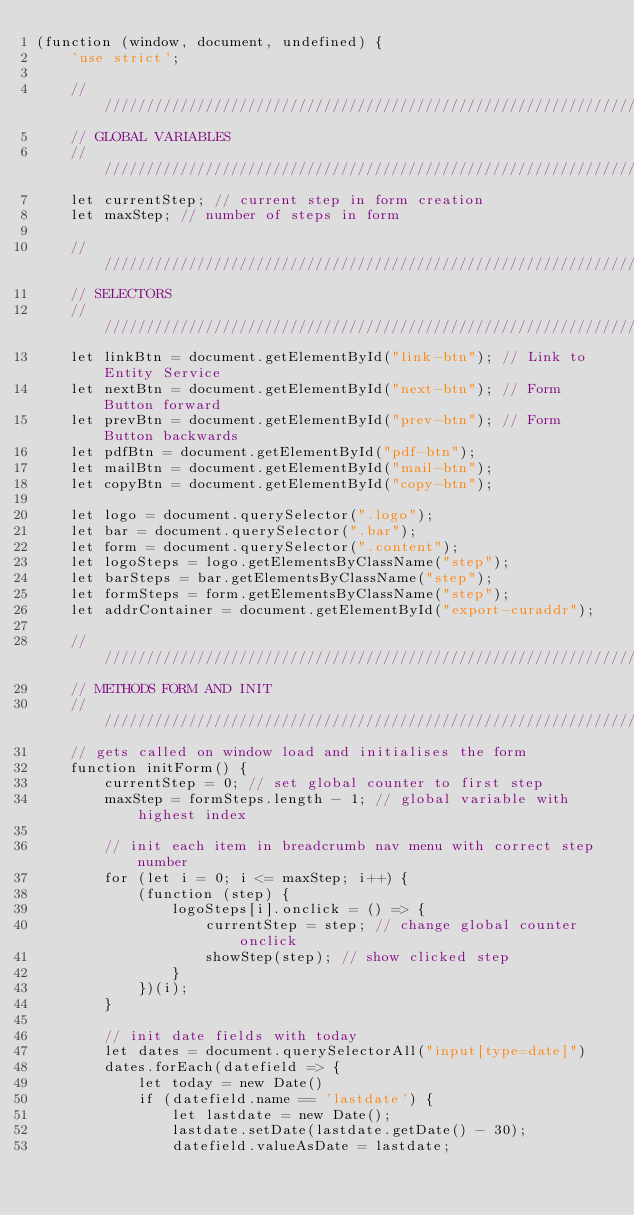<code> <loc_0><loc_0><loc_500><loc_500><_JavaScript_>(function (window, document, undefined) {
    'use strict';

    ////////////////////////////////////////////////////////////////////////////
    // GLOBAL VARIABLES
    ////////////////////////////////////////////////////////////////////////////
    let currentStep; // current step in form creation
    let maxStep; // number of steps in form

    ////////////////////////////////////////////////////////////////////////////
    // SELECTORS
    ////////////////////////////////////////////////////////////////////////////
    let linkBtn = document.getElementById("link-btn"); // Link to Entity Service
    let nextBtn = document.getElementById("next-btn"); // Form Button forward
    let prevBtn = document.getElementById("prev-btn"); // Form Button backwards
    let pdfBtn = document.getElementById("pdf-btn");
    let mailBtn = document.getElementById("mail-btn");
    let copyBtn = document.getElementById("copy-btn");

    let logo = document.querySelector(".logo");
    let bar = document.querySelector(".bar");
    let form = document.querySelector(".content");
    let logoSteps = logo.getElementsByClassName("step");
    let barSteps = bar.getElementsByClassName("step");
    let formSteps = form.getElementsByClassName("step");
    let addrContainer = document.getElementById("export-curaddr");

    ////////////////////////////////////////////////////////////////////////////
    // METHODS FORM AND INIT
    ////////////////////////////////////////////////////////////////////////////
    // gets called on window load and initialises the form
    function initForm() {
        currentStep = 0; // set global counter to first step
        maxStep = formSteps.length - 1; // global variable with highest index

        // init each item in breadcrumb nav menu with correct step number
        for (let i = 0; i <= maxStep; i++) {
            (function (step) {
                logoSteps[i].onclick = () => {
                    currentStep = step; // change global counter onclick
                    showStep(step); // show clicked step
                }
            })(i);
        }

        // init date fields with today
        let dates = document.querySelectorAll("input[type=date]")
        dates.forEach(datefield => {
            let today = new Date()
            if (datefield.name == 'lastdate') {
                let lastdate = new Date();
                lastdate.setDate(lastdate.getDate() - 30);
                datefield.valueAsDate = lastdate;</code> 